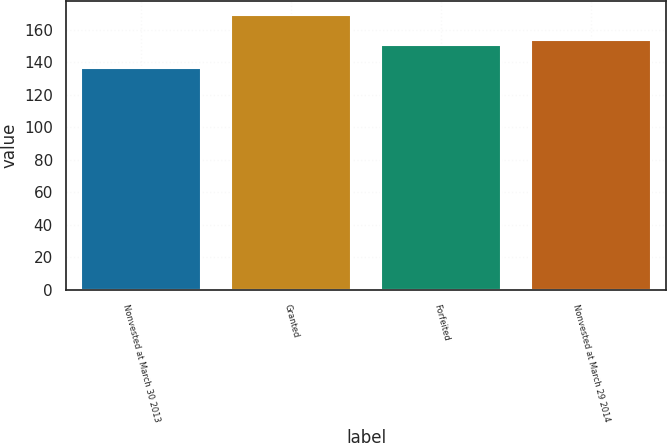Convert chart. <chart><loc_0><loc_0><loc_500><loc_500><bar_chart><fcel>Nonvested at March 30 2013<fcel>Granted<fcel>Forfeited<fcel>Nonvested at March 29 2014<nl><fcel>136.16<fcel>169.14<fcel>150.32<fcel>153.62<nl></chart> 